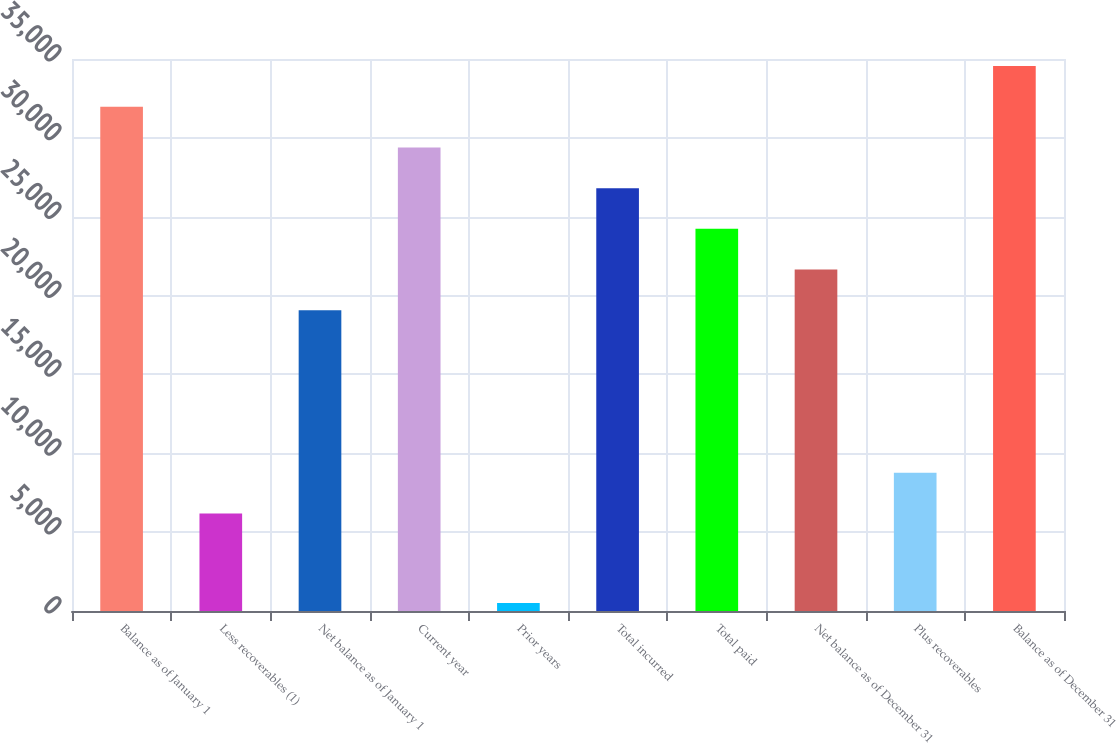<chart> <loc_0><loc_0><loc_500><loc_500><bar_chart><fcel>Balance as of January 1<fcel>Less recoverables (1)<fcel>Net balance as of January 1<fcel>Current year<fcel>Prior years<fcel>Total incurred<fcel>Total paid<fcel>Net balance as of December 31<fcel>Plus recoverables<fcel>Balance as of December 31<nl><fcel>31977<fcel>6184<fcel>19066<fcel>29394.8<fcel>503<fcel>26812.6<fcel>24230.4<fcel>21648.2<fcel>8766.2<fcel>34559.2<nl></chart> 